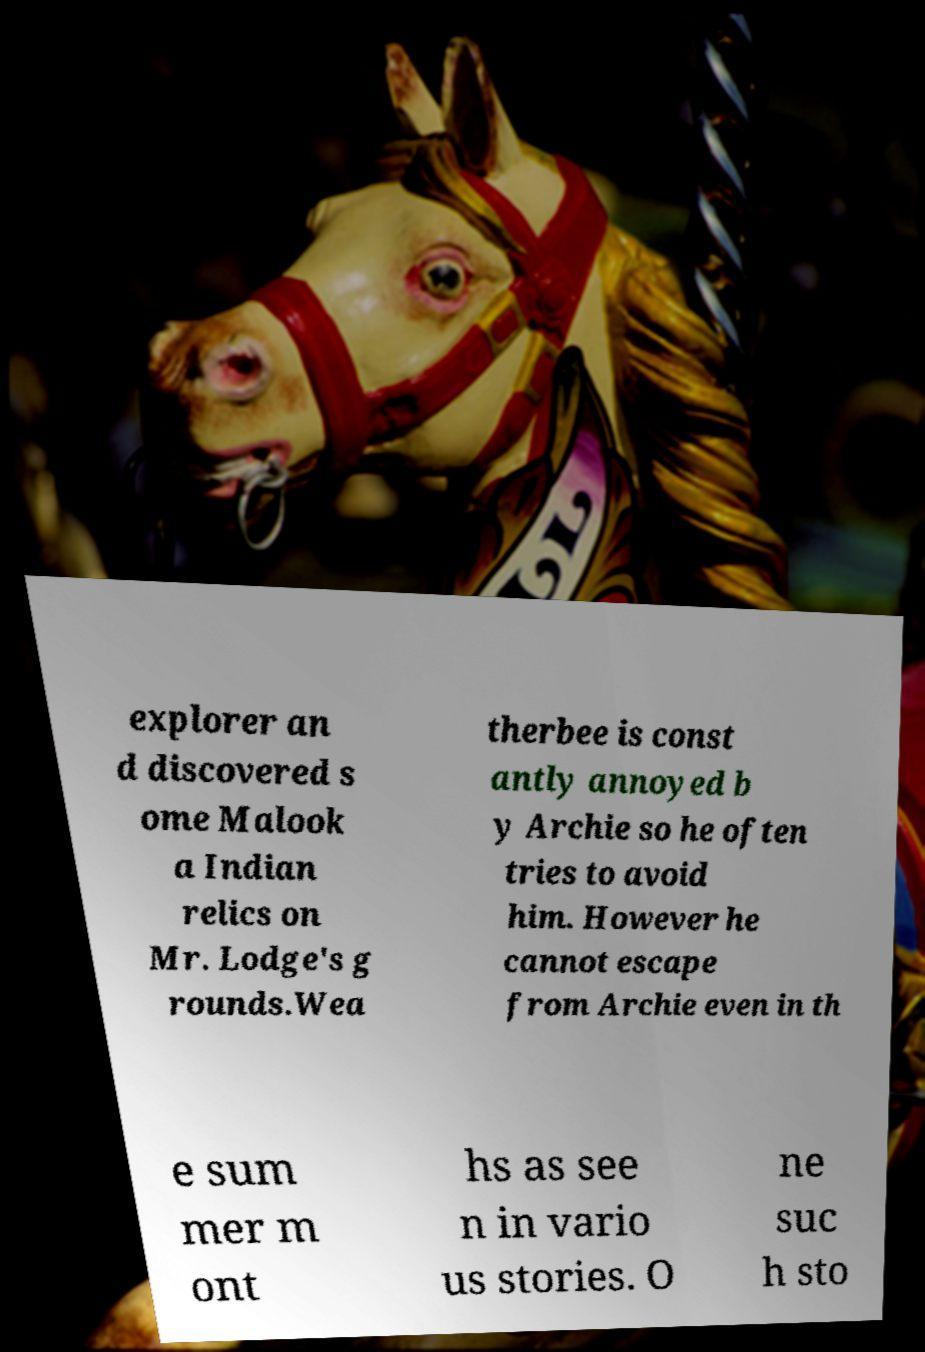I need the written content from this picture converted into text. Can you do that? explorer an d discovered s ome Malook a Indian relics on Mr. Lodge's g rounds.Wea therbee is const antly annoyed b y Archie so he often tries to avoid him. However he cannot escape from Archie even in th e sum mer m ont hs as see n in vario us stories. O ne suc h sto 